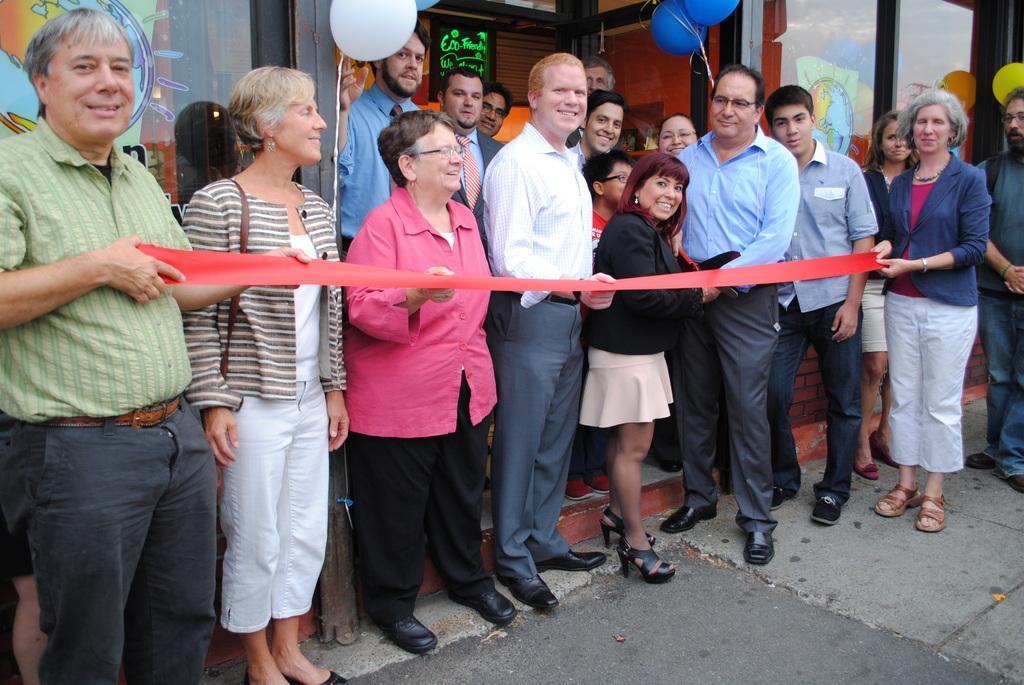How would you summarize this image in a sentence or two? In this image we can see the persons standing on the path and smiling and also holding the red color ribbon. In the background we can see the balloons and also the glass windows. We can also see the text board. 